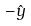Convert formula to latex. <formula><loc_0><loc_0><loc_500><loc_500>- \hat { y }</formula> 